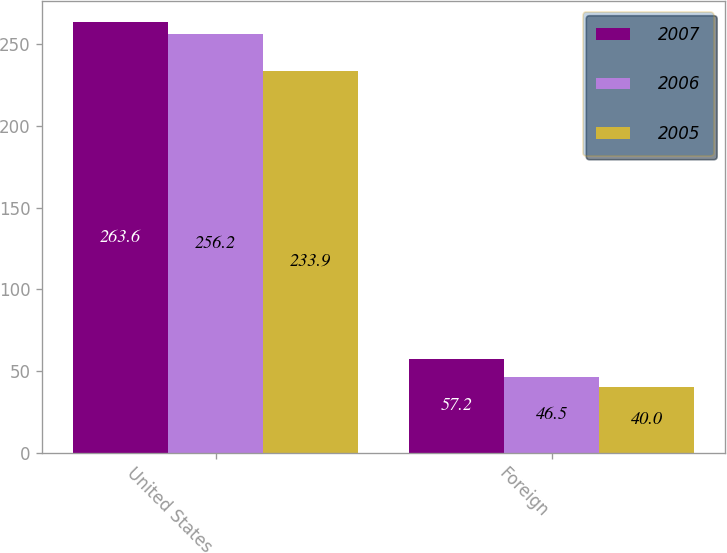<chart> <loc_0><loc_0><loc_500><loc_500><stacked_bar_chart><ecel><fcel>United States<fcel>Foreign<nl><fcel>2007<fcel>263.6<fcel>57.2<nl><fcel>2006<fcel>256.2<fcel>46.5<nl><fcel>2005<fcel>233.9<fcel>40<nl></chart> 